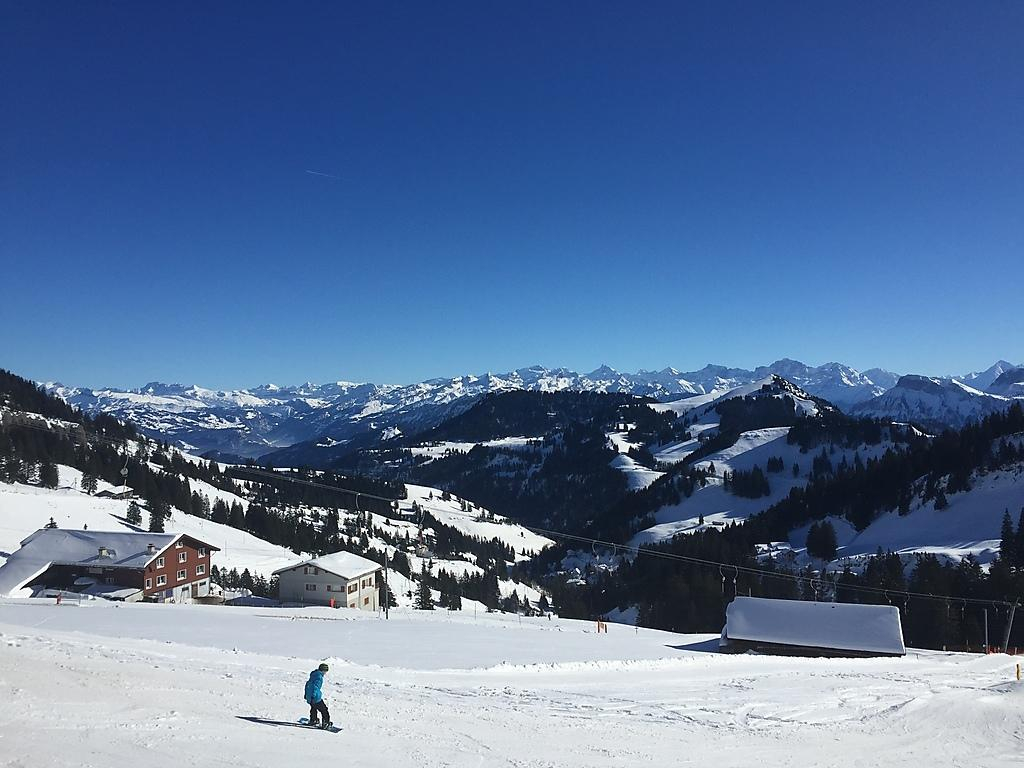Who or what is present in the image? There is a person in the image. What type of structures can be seen in the image? There are buildings in the image. What is the weather like in the image? There is snow visible in the image, indicating a cold or wintery environment. What can be seen in the background of the image? There are trees and mountains in the background of the image. What is the condition of the sky in the image? The sky is clear in the image. What type of bubble can be seen floating near the person in the image? There is no bubble present in the image; it features a person in a snowy environment with buildings, trees, mountains, and a clear sky. 